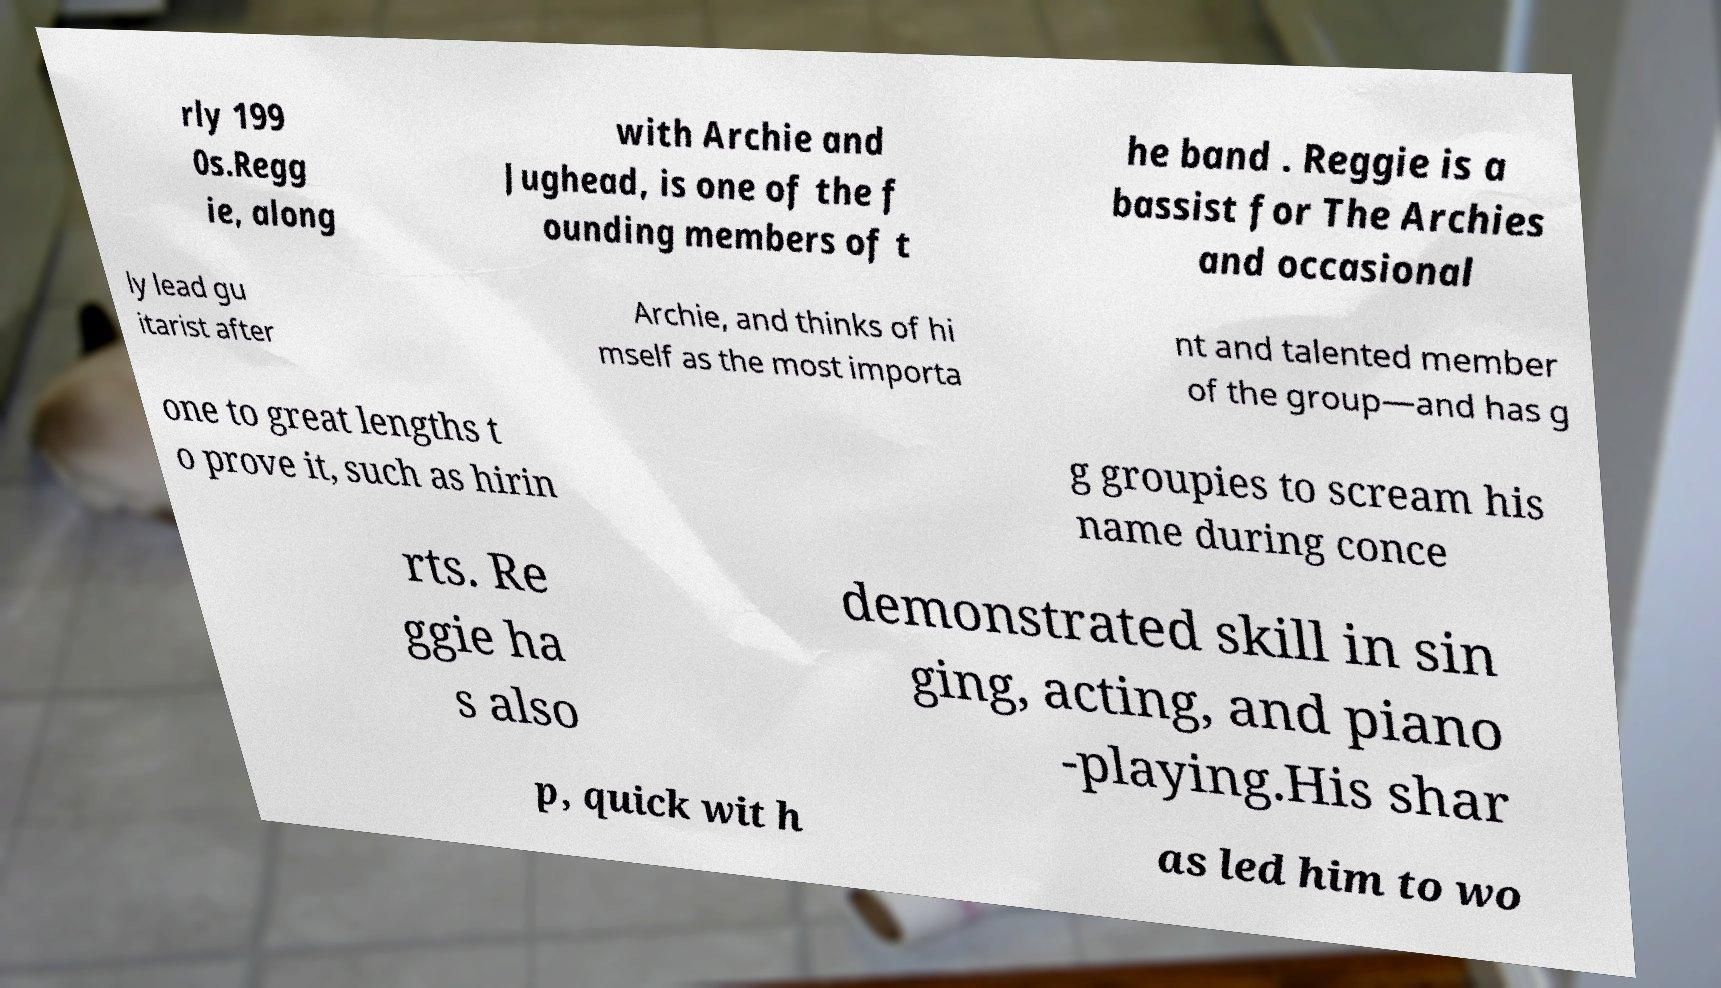Could you extract and type out the text from this image? rly 199 0s.Regg ie, along with Archie and Jughead, is one of the f ounding members of t he band . Reggie is a bassist for The Archies and occasional ly lead gu itarist after Archie, and thinks of hi mself as the most importa nt and talented member of the group—and has g one to great lengths t o prove it, such as hirin g groupies to scream his name during conce rts. Re ggie ha s also demonstrated skill in sin ging, acting, and piano -playing.His shar p, quick wit h as led him to wo 